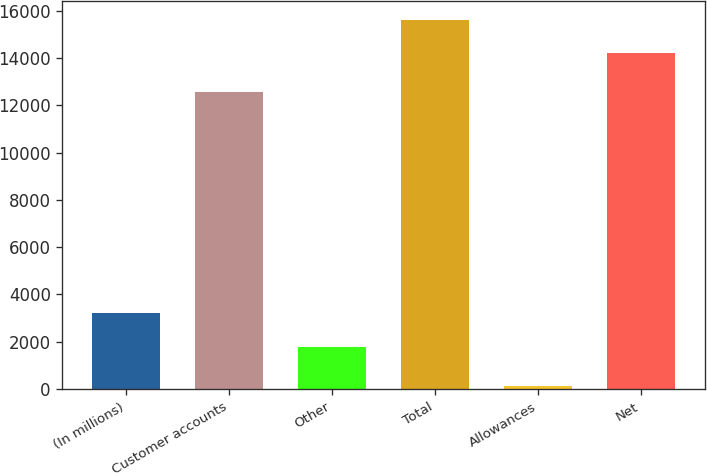<chart> <loc_0><loc_0><loc_500><loc_500><bar_chart><fcel>(In millions)<fcel>Customer accounts<fcel>Other<fcel>Total<fcel>Allowances<fcel>Net<nl><fcel>3199.3<fcel>12543<fcel>1780<fcel>15612.3<fcel>130<fcel>14193<nl></chart> 